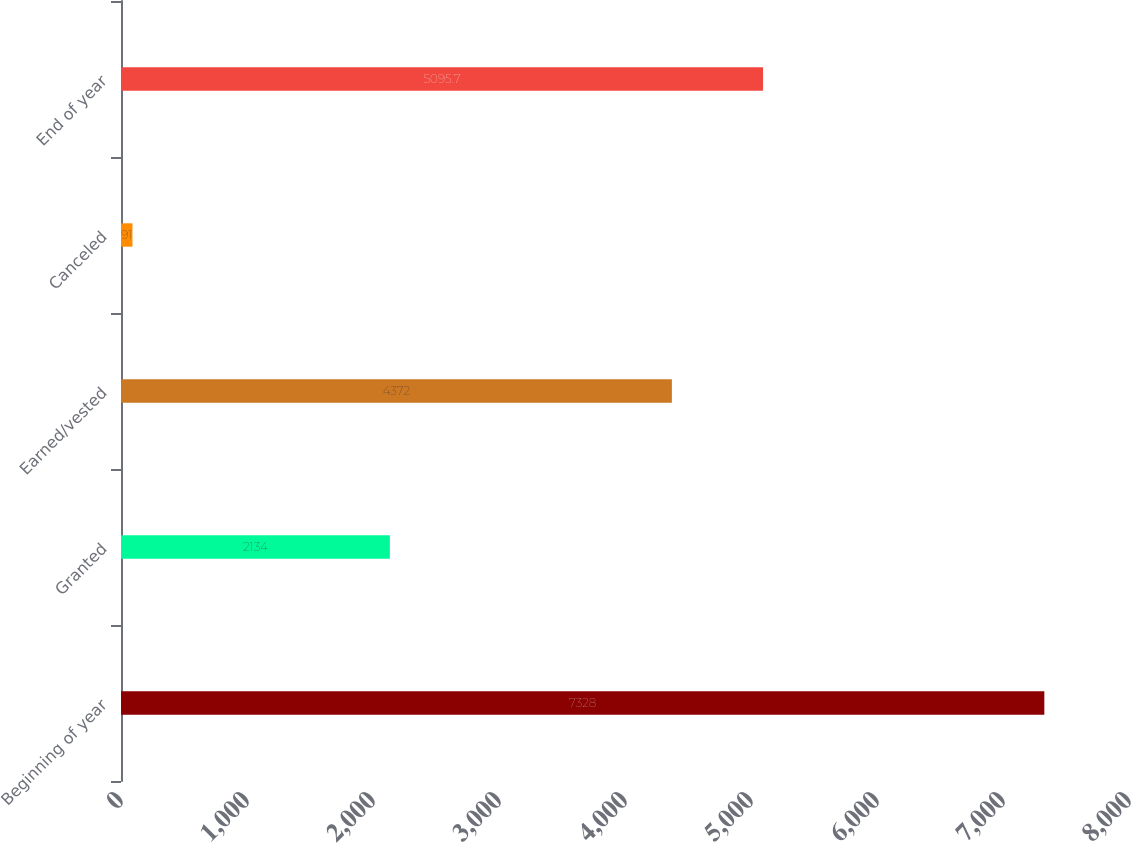Convert chart to OTSL. <chart><loc_0><loc_0><loc_500><loc_500><bar_chart><fcel>Beginning of year<fcel>Granted<fcel>Earned/vested<fcel>Canceled<fcel>End of year<nl><fcel>7328<fcel>2134<fcel>4372<fcel>91<fcel>5095.7<nl></chart> 